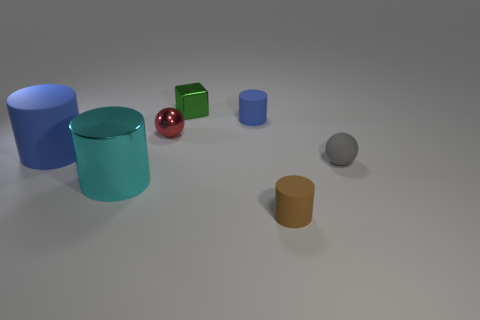Subtract all small blue matte cylinders. How many cylinders are left? 3 Add 2 tiny rubber things. How many objects exist? 9 Subtract all cyan cylinders. How many cylinders are left? 3 Subtract all brown balls. How many blue cylinders are left? 2 Subtract all blocks. How many objects are left? 6 Add 4 green rubber cylinders. How many green rubber cylinders exist? 4 Subtract 0 gray cylinders. How many objects are left? 7 Subtract all blue cylinders. Subtract all green blocks. How many cylinders are left? 2 Subtract all small purple things. Subtract all small blue matte cylinders. How many objects are left? 6 Add 7 cyan metallic cylinders. How many cyan metallic cylinders are left? 8 